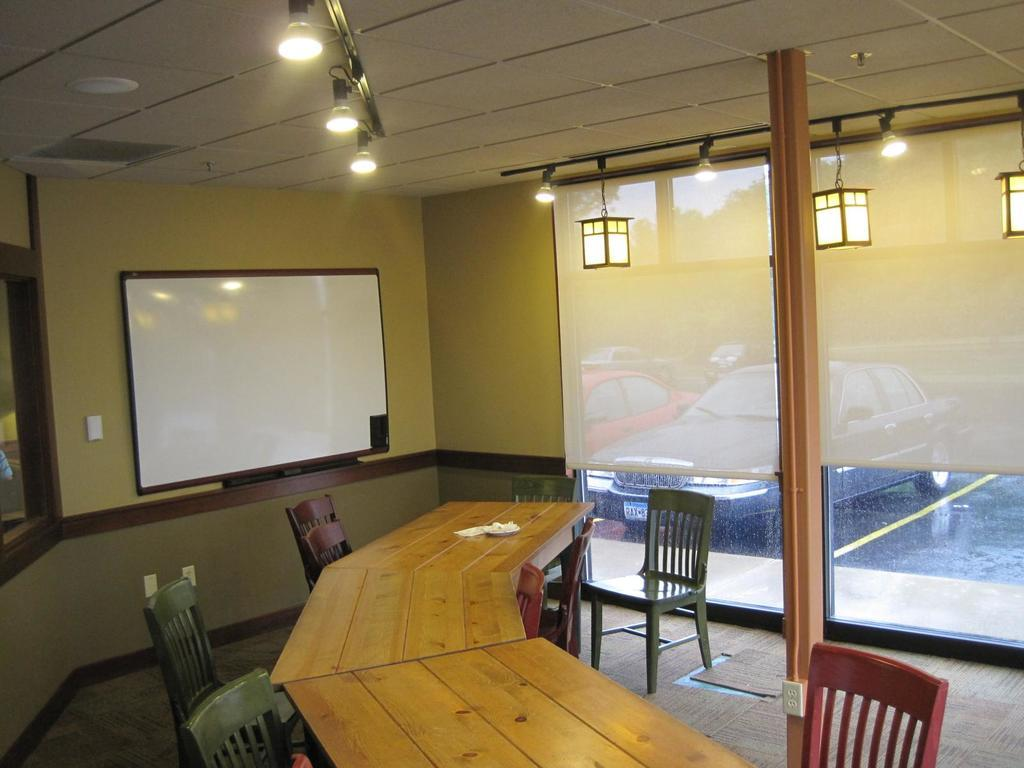What type of lighting is present in the image? There are electric lights in the image. What can be seen on the display screen in the image? The content of the display screen is not visible in the image. What type of furniture is present in the image? There are chairs and desks in the image. What is the flooring like in the image? The floor is visible in the image, and there is a carpet present. What type of window treatment is present in the image? There are curtains in the image. What is the outdoor setting visible in the image? There is a car and a road in the image. What type of picture is hanging on the wall in the image? There is no mention of a picture hanging on the wall in the image. What selection of items can be seen on the desks in the image? The content of the desks is not visible in the image, so it is not possible to determine what items are present. 